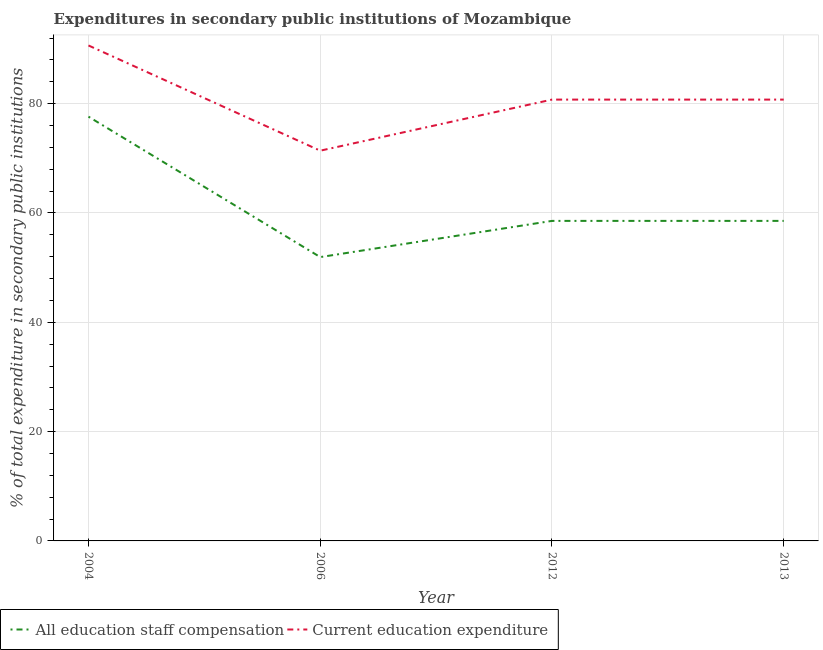How many different coloured lines are there?
Provide a succinct answer. 2. Does the line corresponding to expenditure in staff compensation intersect with the line corresponding to expenditure in education?
Your answer should be very brief. No. What is the expenditure in education in 2006?
Give a very brief answer. 71.39. Across all years, what is the maximum expenditure in staff compensation?
Ensure brevity in your answer.  77.62. Across all years, what is the minimum expenditure in education?
Your answer should be very brief. 71.39. In which year was the expenditure in education minimum?
Offer a terse response. 2006. What is the total expenditure in education in the graph?
Give a very brief answer. 323.52. What is the difference between the expenditure in education in 2004 and that in 2012?
Provide a succinct answer. 9.9. What is the difference between the expenditure in education in 2004 and the expenditure in staff compensation in 2006?
Offer a very short reply. 38.72. What is the average expenditure in education per year?
Ensure brevity in your answer.  80.88. In the year 2004, what is the difference between the expenditure in staff compensation and expenditure in education?
Your response must be concise. -13.02. What is the ratio of the expenditure in staff compensation in 2004 to that in 2013?
Your answer should be very brief. 1.33. Is the expenditure in staff compensation in 2004 less than that in 2012?
Your answer should be compact. No. Is the difference between the expenditure in education in 2012 and 2013 greater than the difference between the expenditure in staff compensation in 2012 and 2013?
Your response must be concise. No. What is the difference between the highest and the second highest expenditure in staff compensation?
Your response must be concise. 19.07. What is the difference between the highest and the lowest expenditure in staff compensation?
Keep it short and to the point. 25.69. In how many years, is the expenditure in staff compensation greater than the average expenditure in staff compensation taken over all years?
Your response must be concise. 1. Is the sum of the expenditure in education in 2004 and 2013 greater than the maximum expenditure in staff compensation across all years?
Provide a succinct answer. Yes. Is the expenditure in staff compensation strictly greater than the expenditure in education over the years?
Provide a short and direct response. No. How many lines are there?
Make the answer very short. 2. What is the difference between two consecutive major ticks on the Y-axis?
Provide a short and direct response. 20. Does the graph contain any zero values?
Ensure brevity in your answer.  No. Does the graph contain grids?
Your answer should be very brief. Yes. Where does the legend appear in the graph?
Offer a very short reply. Bottom left. How many legend labels are there?
Ensure brevity in your answer.  2. What is the title of the graph?
Your answer should be very brief. Expenditures in secondary public institutions of Mozambique. Does "Crop" appear as one of the legend labels in the graph?
Your answer should be very brief. No. What is the label or title of the X-axis?
Offer a terse response. Year. What is the label or title of the Y-axis?
Keep it short and to the point. % of total expenditure in secondary public institutions. What is the % of total expenditure in secondary public institutions in All education staff compensation in 2004?
Offer a terse response. 77.62. What is the % of total expenditure in secondary public institutions in Current education expenditure in 2004?
Your response must be concise. 90.64. What is the % of total expenditure in secondary public institutions of All education staff compensation in 2006?
Your response must be concise. 51.93. What is the % of total expenditure in secondary public institutions of Current education expenditure in 2006?
Your answer should be very brief. 71.39. What is the % of total expenditure in secondary public institutions of All education staff compensation in 2012?
Offer a very short reply. 58.55. What is the % of total expenditure in secondary public institutions of Current education expenditure in 2012?
Keep it short and to the point. 80.74. What is the % of total expenditure in secondary public institutions in All education staff compensation in 2013?
Offer a very short reply. 58.55. What is the % of total expenditure in secondary public institutions in Current education expenditure in 2013?
Your answer should be compact. 80.74. Across all years, what is the maximum % of total expenditure in secondary public institutions in All education staff compensation?
Offer a terse response. 77.62. Across all years, what is the maximum % of total expenditure in secondary public institutions in Current education expenditure?
Offer a terse response. 90.64. Across all years, what is the minimum % of total expenditure in secondary public institutions of All education staff compensation?
Offer a terse response. 51.93. Across all years, what is the minimum % of total expenditure in secondary public institutions in Current education expenditure?
Provide a succinct answer. 71.39. What is the total % of total expenditure in secondary public institutions of All education staff compensation in the graph?
Make the answer very short. 246.64. What is the total % of total expenditure in secondary public institutions of Current education expenditure in the graph?
Offer a very short reply. 323.52. What is the difference between the % of total expenditure in secondary public institutions of All education staff compensation in 2004 and that in 2006?
Your answer should be compact. 25.69. What is the difference between the % of total expenditure in secondary public institutions in Current education expenditure in 2004 and that in 2006?
Ensure brevity in your answer.  19.25. What is the difference between the % of total expenditure in secondary public institutions of All education staff compensation in 2004 and that in 2012?
Your response must be concise. 19.07. What is the difference between the % of total expenditure in secondary public institutions in Current education expenditure in 2004 and that in 2012?
Provide a succinct answer. 9.9. What is the difference between the % of total expenditure in secondary public institutions in All education staff compensation in 2004 and that in 2013?
Make the answer very short. 19.07. What is the difference between the % of total expenditure in secondary public institutions in Current education expenditure in 2004 and that in 2013?
Ensure brevity in your answer.  9.9. What is the difference between the % of total expenditure in secondary public institutions of All education staff compensation in 2006 and that in 2012?
Make the answer very short. -6.62. What is the difference between the % of total expenditure in secondary public institutions of Current education expenditure in 2006 and that in 2012?
Offer a terse response. -9.35. What is the difference between the % of total expenditure in secondary public institutions of All education staff compensation in 2006 and that in 2013?
Offer a very short reply. -6.62. What is the difference between the % of total expenditure in secondary public institutions in Current education expenditure in 2006 and that in 2013?
Keep it short and to the point. -9.35. What is the difference between the % of total expenditure in secondary public institutions in All education staff compensation in 2012 and that in 2013?
Keep it short and to the point. 0. What is the difference between the % of total expenditure in secondary public institutions of All education staff compensation in 2004 and the % of total expenditure in secondary public institutions of Current education expenditure in 2006?
Offer a terse response. 6.23. What is the difference between the % of total expenditure in secondary public institutions in All education staff compensation in 2004 and the % of total expenditure in secondary public institutions in Current education expenditure in 2012?
Give a very brief answer. -3.12. What is the difference between the % of total expenditure in secondary public institutions of All education staff compensation in 2004 and the % of total expenditure in secondary public institutions of Current education expenditure in 2013?
Keep it short and to the point. -3.12. What is the difference between the % of total expenditure in secondary public institutions in All education staff compensation in 2006 and the % of total expenditure in secondary public institutions in Current education expenditure in 2012?
Make the answer very short. -28.82. What is the difference between the % of total expenditure in secondary public institutions of All education staff compensation in 2006 and the % of total expenditure in secondary public institutions of Current education expenditure in 2013?
Make the answer very short. -28.82. What is the difference between the % of total expenditure in secondary public institutions in All education staff compensation in 2012 and the % of total expenditure in secondary public institutions in Current education expenditure in 2013?
Provide a short and direct response. -22.19. What is the average % of total expenditure in secondary public institutions of All education staff compensation per year?
Keep it short and to the point. 61.66. What is the average % of total expenditure in secondary public institutions of Current education expenditure per year?
Offer a terse response. 80.88. In the year 2004, what is the difference between the % of total expenditure in secondary public institutions of All education staff compensation and % of total expenditure in secondary public institutions of Current education expenditure?
Your answer should be compact. -13.02. In the year 2006, what is the difference between the % of total expenditure in secondary public institutions of All education staff compensation and % of total expenditure in secondary public institutions of Current education expenditure?
Provide a succinct answer. -19.47. In the year 2012, what is the difference between the % of total expenditure in secondary public institutions of All education staff compensation and % of total expenditure in secondary public institutions of Current education expenditure?
Make the answer very short. -22.19. In the year 2013, what is the difference between the % of total expenditure in secondary public institutions of All education staff compensation and % of total expenditure in secondary public institutions of Current education expenditure?
Your response must be concise. -22.19. What is the ratio of the % of total expenditure in secondary public institutions in All education staff compensation in 2004 to that in 2006?
Provide a succinct answer. 1.49. What is the ratio of the % of total expenditure in secondary public institutions of Current education expenditure in 2004 to that in 2006?
Your answer should be very brief. 1.27. What is the ratio of the % of total expenditure in secondary public institutions in All education staff compensation in 2004 to that in 2012?
Provide a short and direct response. 1.33. What is the ratio of the % of total expenditure in secondary public institutions of Current education expenditure in 2004 to that in 2012?
Your answer should be compact. 1.12. What is the ratio of the % of total expenditure in secondary public institutions in All education staff compensation in 2004 to that in 2013?
Make the answer very short. 1.33. What is the ratio of the % of total expenditure in secondary public institutions of Current education expenditure in 2004 to that in 2013?
Keep it short and to the point. 1.12. What is the ratio of the % of total expenditure in secondary public institutions of All education staff compensation in 2006 to that in 2012?
Give a very brief answer. 0.89. What is the ratio of the % of total expenditure in secondary public institutions of Current education expenditure in 2006 to that in 2012?
Your answer should be very brief. 0.88. What is the ratio of the % of total expenditure in secondary public institutions in All education staff compensation in 2006 to that in 2013?
Offer a terse response. 0.89. What is the ratio of the % of total expenditure in secondary public institutions of Current education expenditure in 2006 to that in 2013?
Offer a very short reply. 0.88. What is the ratio of the % of total expenditure in secondary public institutions of All education staff compensation in 2012 to that in 2013?
Provide a succinct answer. 1. What is the difference between the highest and the second highest % of total expenditure in secondary public institutions of All education staff compensation?
Your answer should be very brief. 19.07. What is the difference between the highest and the second highest % of total expenditure in secondary public institutions of Current education expenditure?
Offer a very short reply. 9.9. What is the difference between the highest and the lowest % of total expenditure in secondary public institutions in All education staff compensation?
Offer a terse response. 25.69. What is the difference between the highest and the lowest % of total expenditure in secondary public institutions in Current education expenditure?
Provide a succinct answer. 19.25. 